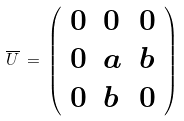Convert formula to latex. <formula><loc_0><loc_0><loc_500><loc_500>\overline { U } \, = \, \left ( \begin{array} { l l l } 0 & 0 & 0 \\ 0 & a & b \\ 0 & b & 0 \end{array} \right ) \,</formula> 